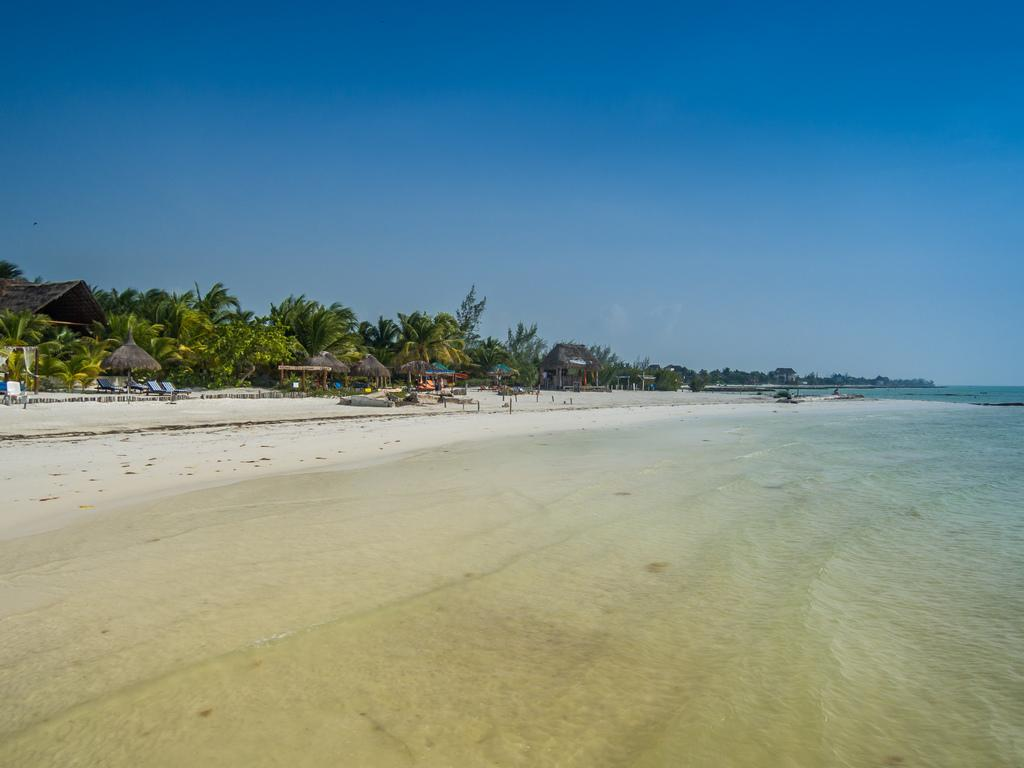What type of view is shown in the image? The image depicts a seaside view. Are there any objects for people to sit on in the image? Yes, there are benches visible in the image. What can be used for shade in the image? There is an umbrella in the image. What type of vegetation is present in the background of the image? Coconut trees are present in the background of the image. What type of guitar can be seen hanging from the coconut tree in the image? There is no guitar present in the image; it only features a seaside view with benches, an umbrella, and coconut trees. 